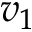<formula> <loc_0><loc_0><loc_500><loc_500>v _ { 1 }</formula> 